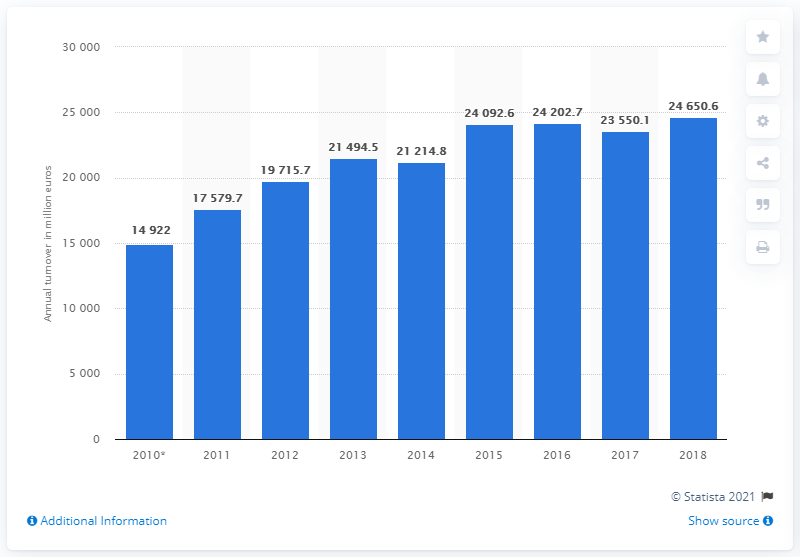Point out several critical features in this image. In 2017, the turnover of the Swiss building construction industry was 24,650.6 million Swiss francs. The turnover of the Swiss building construction industry in 2017 was 23,550.1. 